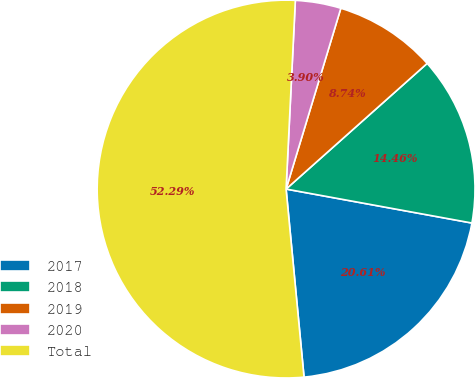<chart> <loc_0><loc_0><loc_500><loc_500><pie_chart><fcel>2017<fcel>2018<fcel>2019<fcel>2020<fcel>Total<nl><fcel>20.61%<fcel>14.46%<fcel>8.74%<fcel>3.9%<fcel>52.3%<nl></chart> 